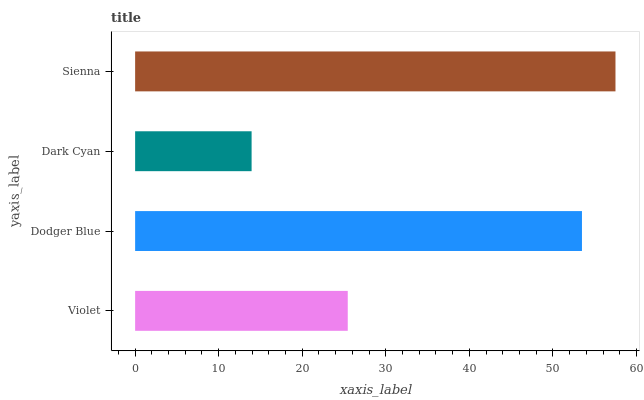Is Dark Cyan the minimum?
Answer yes or no. Yes. Is Sienna the maximum?
Answer yes or no. Yes. Is Dodger Blue the minimum?
Answer yes or no. No. Is Dodger Blue the maximum?
Answer yes or no. No. Is Dodger Blue greater than Violet?
Answer yes or no. Yes. Is Violet less than Dodger Blue?
Answer yes or no. Yes. Is Violet greater than Dodger Blue?
Answer yes or no. No. Is Dodger Blue less than Violet?
Answer yes or no. No. Is Dodger Blue the high median?
Answer yes or no. Yes. Is Violet the low median?
Answer yes or no. Yes. Is Sienna the high median?
Answer yes or no. No. Is Dark Cyan the low median?
Answer yes or no. No. 